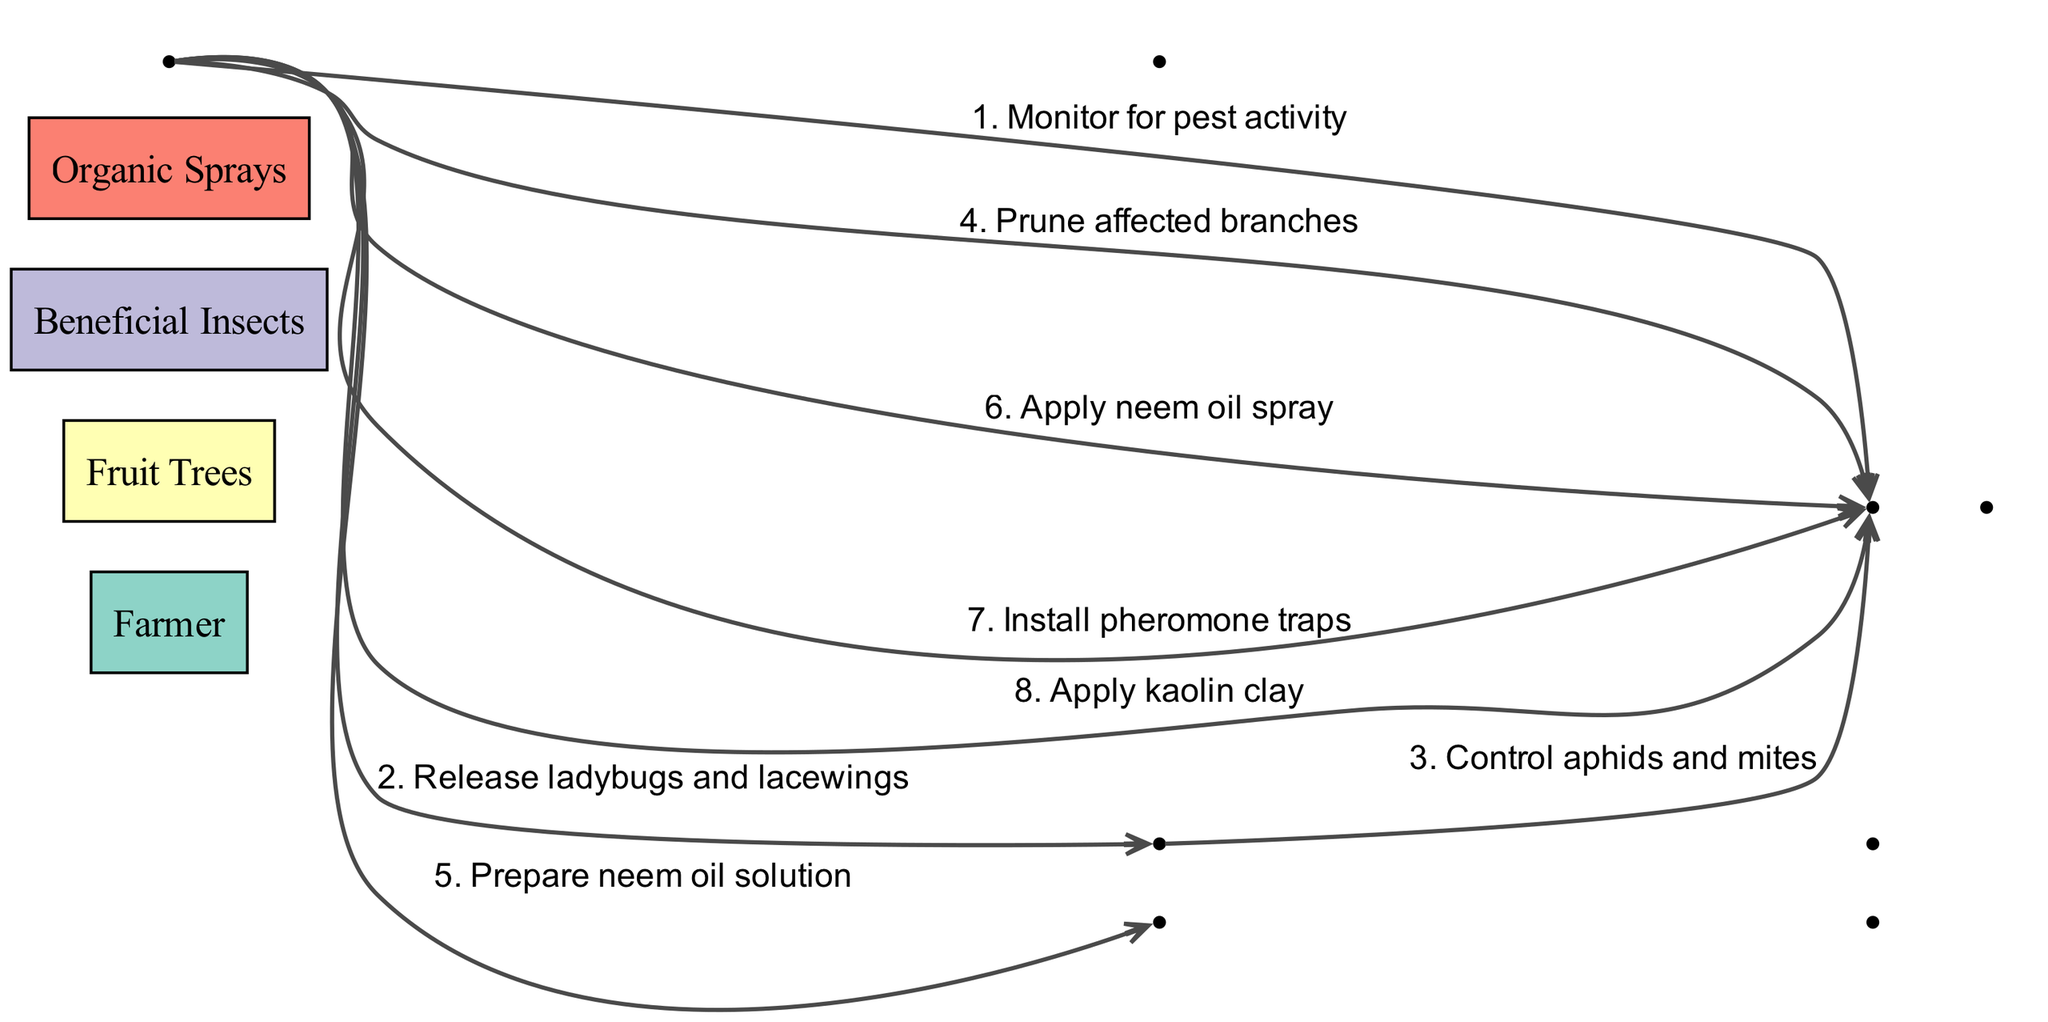What is the first action taken by the Farmer? The diagram shows that the Farmer's first action is to "Monitor for pest activity", which is the first step in the sequence.
Answer: Monitor for pest activity How many actions are there in total? By counting all the individual actions represented in the sequence, there are a total of eight actions listed.
Answer: 8 Which insect is released by the Farmer? According to the diagram, the Farmer releases "ladybugs and lacewings", which is the second action in the sequence.
Answer: ladybugs and lacewings What is the last action taken on the Fruit Trees? The last action in the sequence directed towards the Fruit Trees is "Apply kaolin clay", making it the final step.
Answer: Apply kaolin clay Who controls aphids and mites? The diagram specifies that the "Beneficial Insects" are responsible for controlling aphids and mites, which is the third action in the sequence.
Answer: Beneficial Insects What does the Farmer prepare as the fifth action? The fifth action taken by the Farmer, as indicated in the diagram, is to "Prepare neem oil solution".
Answer: Prepare neem oil solution Which step comes before applying neem oil spray? Before the Farmer applies neem oil spray, the action taken is preparing the neem oil solution, making it the previous step in the sequence.
Answer: Prepare neem oil solution How many actors are involved in this sequence? The diagram lists four actors involved in the sequence: Farmer, Fruit Trees, Beneficial Insects, and Organic Sprays, indicating that there are four actors present.
Answer: 4 In what order do the Farmer's actions directed towards the Fruit Trees occur? The Farmer's actions directed toward the Fruit Trees occur in the following order: monitor for pest activity, prune affected branches, apply neem oil spray, install pheromone traps, and apply kaolin clay, which outlines the specific steps taken by the Farmer.
Answer: Monitor for pest activity, Prune affected branches, Apply neem oil spray, Install pheromone traps, Apply kaolin clay 